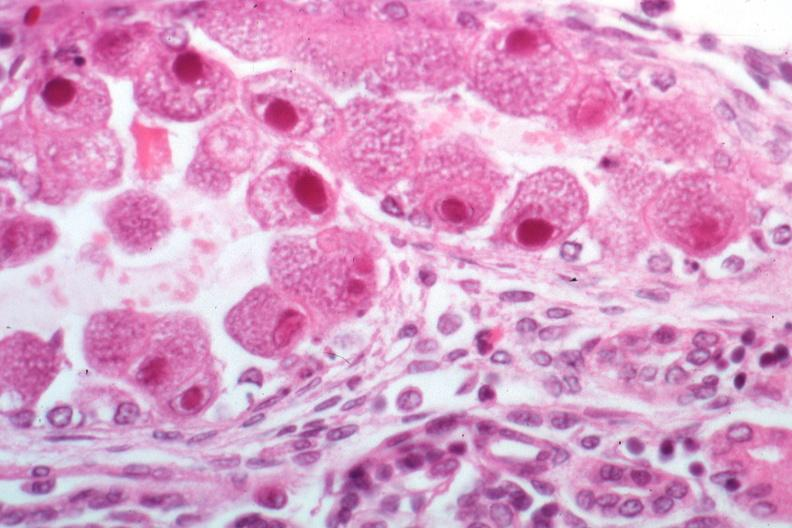where is this?
Answer the question using a single word or phrase. Urinary 